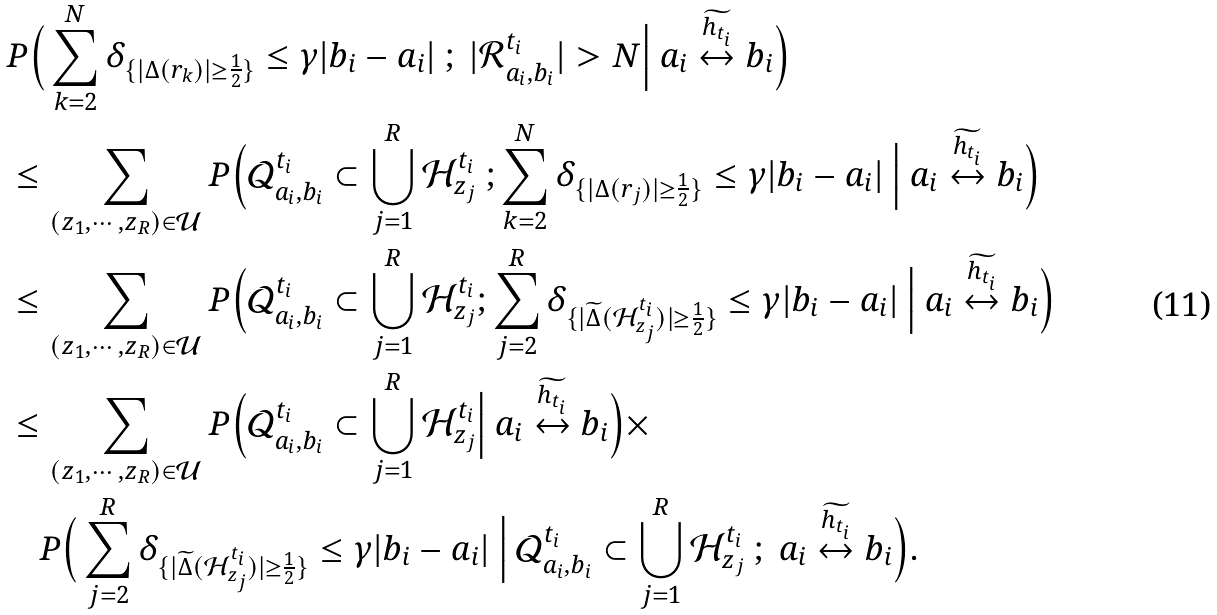Convert formula to latex. <formula><loc_0><loc_0><loc_500><loc_500>& P \Big ( \sum _ { k = 2 } ^ { N } \delta _ { \{ | \Delta ( r _ { k } ) | \geq \frac { 1 } { 2 } \} } \leq \gamma | b _ { i } - a _ { i } | \ ; \ | \mathcal { R } ^ { t _ { i } } _ { a _ { i } , b _ { i } } | > N \Big | \ a _ { i } \overset { \widetilde { h _ { t _ { i } } } } { \leftrightarrow } b _ { i } \Big ) \\ & \leq \sum _ { ( z _ { 1 } , \cdots , z _ { R } ) \in \mathcal { U } } P \Big ( \mathcal { Q } ^ { t _ { i } } _ { a _ { i } , b _ { i } } \subset \bigcup _ { j = 1 } ^ { R } \mathcal { H } _ { z _ { j } } ^ { t _ { i } } \ ; \sum _ { k = 2 } ^ { N } \delta _ { \{ | \Delta ( r _ { j } ) | \geq \frac { 1 } { 2 } \} } \leq \gamma | b _ { i } - a _ { i } | \ \Big | \ a _ { i } \overset { \widetilde { h _ { t _ { i } } } } { \leftrightarrow } b _ { i } \Big ) \\ & \leq \sum _ { ( z _ { 1 } , \cdots , z _ { R } ) \in \mathcal { U } } P \Big ( \mathcal { Q } ^ { t _ { i } } _ { a _ { i } , b _ { i } } \subset \bigcup _ { j = 1 } ^ { R } \mathcal { H } _ { z _ { j } } ^ { t _ { i } } ; \sum _ { j = 2 } ^ { R } \delta _ { \{ | \widetilde { \Delta } ( \mathcal { H } ^ { t _ { i } } _ { z _ { j } } ) | \geq \frac { 1 } { 2 } \} } \leq \gamma | b _ { i } - a _ { i } | \ \Big | \ a _ { i } \overset { \widetilde { h _ { t _ { i } } } } { \leftrightarrow } b _ { i } \Big ) \\ & \leq \sum _ { ( z _ { 1 } , \cdots , z _ { R } ) \in \mathcal { U } } P \Big ( \mathcal { Q } ^ { t _ { i } } _ { a _ { i } , b _ { i } } \subset \bigcup _ { j = 1 } ^ { R } \mathcal { H } _ { z _ { j } } ^ { t _ { i } } \Big | \ a _ { i } \overset { \widetilde { h _ { t _ { i } } } } { \leftrightarrow } b _ { i } \Big ) \times \\ & \quad P \Big ( \sum _ { j = 2 } ^ { R } \delta _ { \{ | \widetilde { \Delta } ( \mathcal { H } ^ { t _ { i } } _ { z _ { j } } ) | \geq \frac { 1 } { 2 } \} } \leq \gamma | b _ { i } - a _ { i } | \ \Big | \ \mathcal { Q } ^ { t _ { i } } _ { a _ { i } , b _ { i } } \subset \bigcup _ { j = 1 } ^ { R } \mathcal { H } _ { z _ { j } } ^ { t _ { i } } \ ; \ a _ { i } \overset { \widetilde { h _ { t _ { i } } } } { \leftrightarrow } b _ { i } \Big ) .</formula> 